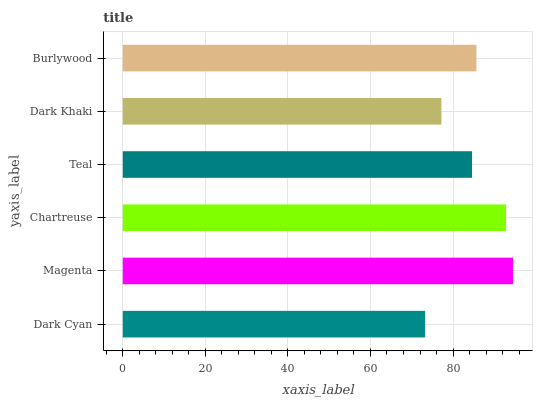Is Dark Cyan the minimum?
Answer yes or no. Yes. Is Magenta the maximum?
Answer yes or no. Yes. Is Chartreuse the minimum?
Answer yes or no. No. Is Chartreuse the maximum?
Answer yes or no. No. Is Magenta greater than Chartreuse?
Answer yes or no. Yes. Is Chartreuse less than Magenta?
Answer yes or no. Yes. Is Chartreuse greater than Magenta?
Answer yes or no. No. Is Magenta less than Chartreuse?
Answer yes or no. No. Is Burlywood the high median?
Answer yes or no. Yes. Is Teal the low median?
Answer yes or no. Yes. Is Dark Khaki the high median?
Answer yes or no. No. Is Dark Cyan the low median?
Answer yes or no. No. 